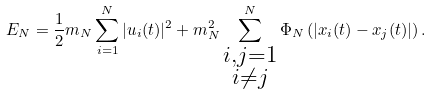Convert formula to latex. <formula><loc_0><loc_0><loc_500><loc_500>E _ { N } = \frac { 1 } { 2 } { m _ { N } } \sum _ { i = 1 } ^ { N } | u _ { i } ( t ) | ^ { 2 } + m _ { N } ^ { 2 } \sum _ { \substack { i , j = 1 \\ i \neq j } } ^ { N } \Phi _ { N } \left ( | x _ { i } ( t ) - x _ { j } ( t ) | \right ) .</formula> 